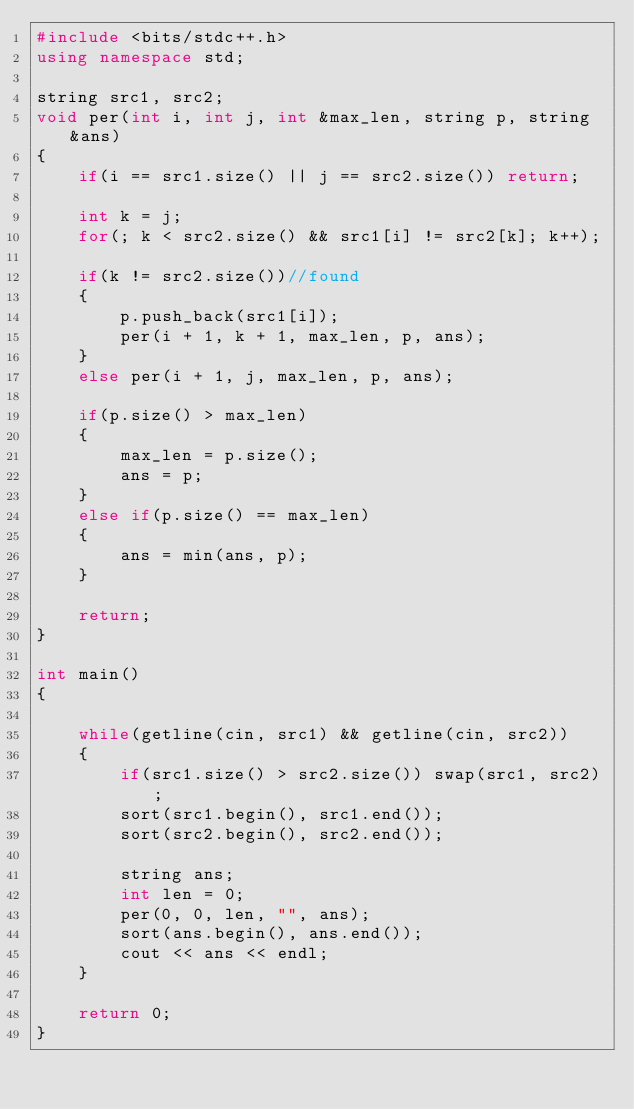<code> <loc_0><loc_0><loc_500><loc_500><_C++_>#include <bits/stdc++.h>
using namespace std;

string src1, src2;
void per(int i, int j, int &max_len, string p, string &ans)
{
    if(i == src1.size() || j == src2.size()) return;

    int k = j;
    for(; k < src2.size() && src1[i] != src2[k]; k++);

    if(k != src2.size())//found
    {
        p.push_back(src1[i]);
        per(i + 1, k + 1, max_len, p, ans);
    }
    else per(i + 1, j, max_len, p, ans);

    if(p.size() > max_len)
    {
        max_len = p.size();
        ans = p;
    }
    else if(p.size() == max_len)
    {
        ans = min(ans, p);
    }

    return;
}

int main()
{
    
    while(getline(cin, src1) && getline(cin, src2))
    {
        if(src1.size() > src2.size()) swap(src1, src2);
        sort(src1.begin(), src1.end());
        sort(src2.begin(), src2.end());

        string ans;
        int len = 0;
        per(0, 0, len, "", ans);
        sort(ans.begin(), ans.end());
        cout << ans << endl;
    }

    return 0;
}</code> 